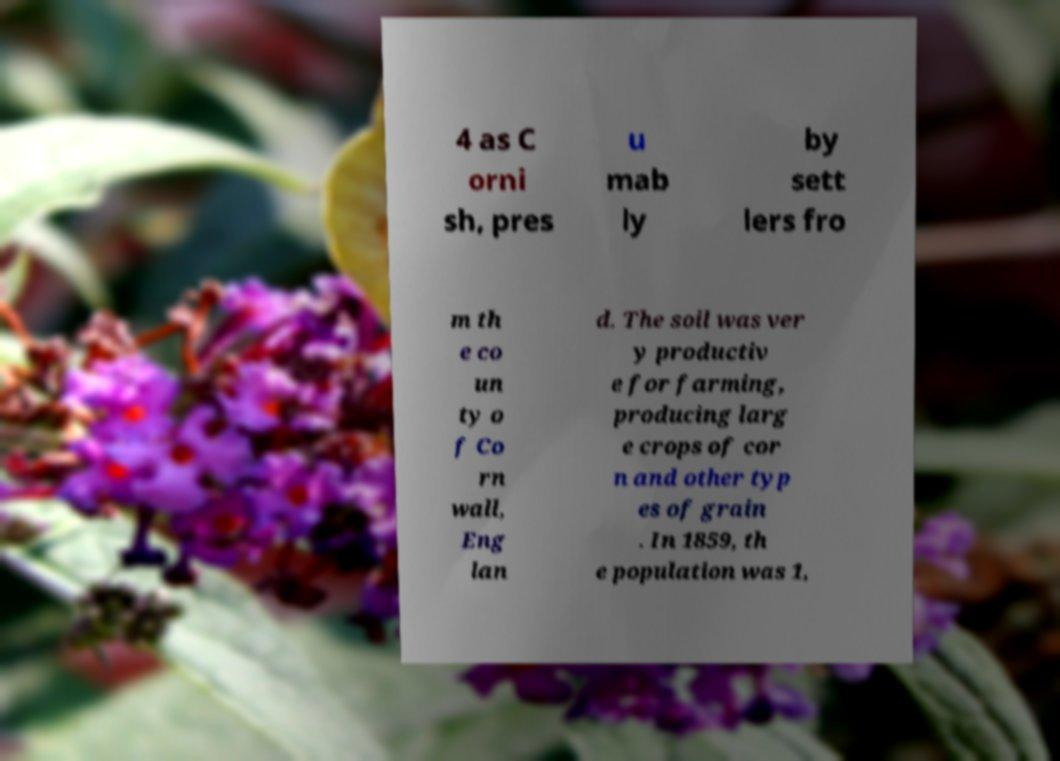What messages or text are displayed in this image? I need them in a readable, typed format. 4 as C orni sh, pres u mab ly by sett lers fro m th e co un ty o f Co rn wall, Eng lan d. The soil was ver y productiv e for farming, producing larg e crops of cor n and other typ es of grain . In 1859, th e population was 1, 